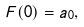Convert formula to latex. <formula><loc_0><loc_0><loc_500><loc_500>F ( 0 ) = a _ { 0 } ,</formula> 